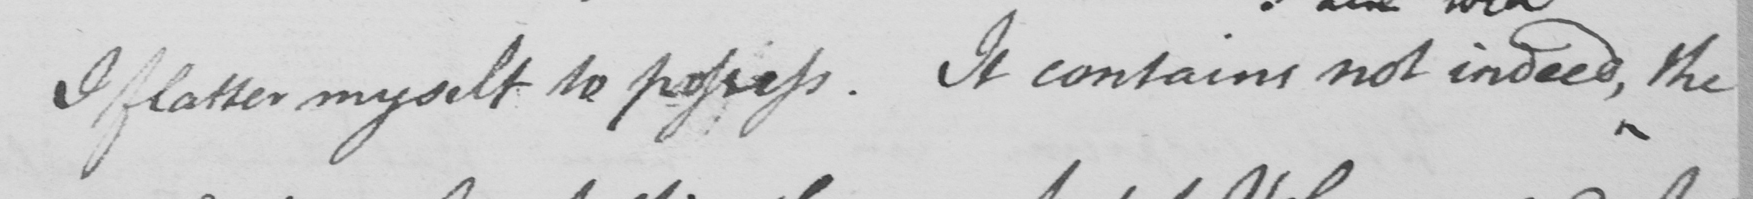What does this handwritten line say? I flatter myself to possess . It contains not indeed , the 